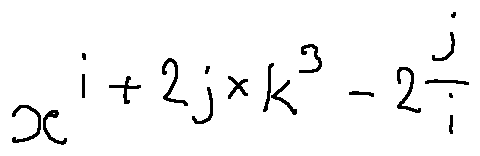Convert formula to latex. <formula><loc_0><loc_0><loc_500><loc_500>x ^ { i + 2 j \times k ^ { 3 } - 2 \frac { j } { i } }</formula> 